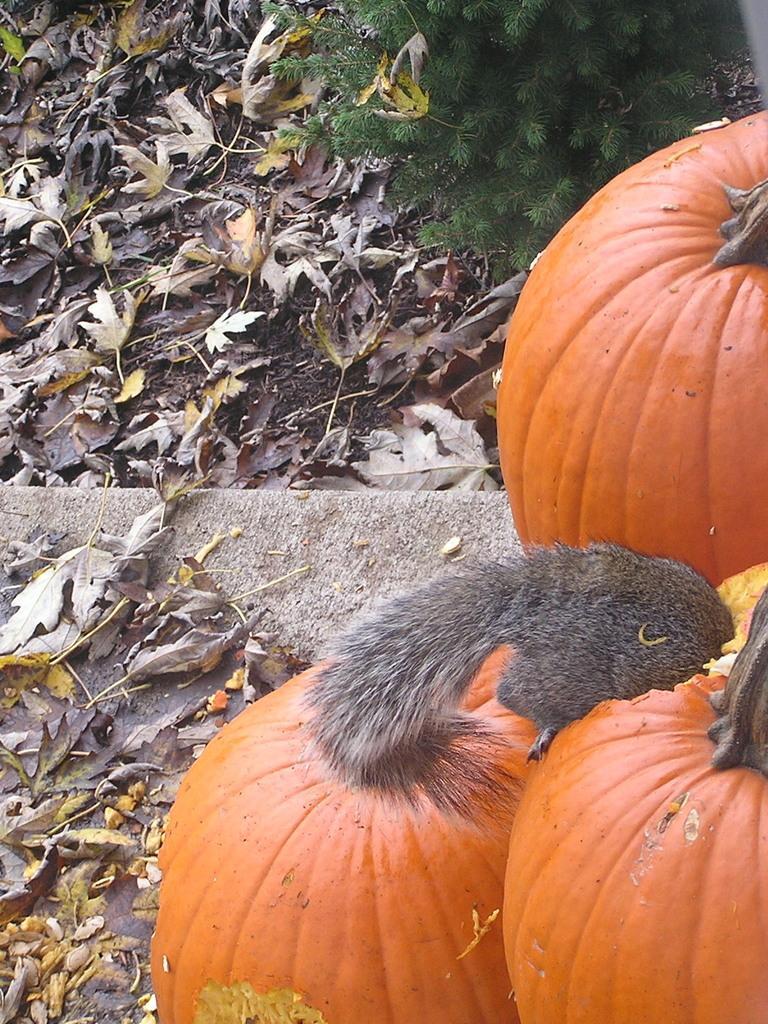In one or two sentences, can you explain what this image depicts? There are three pumpkins. This looks like an animal. These are the dried leaves. I think this is a plant. 